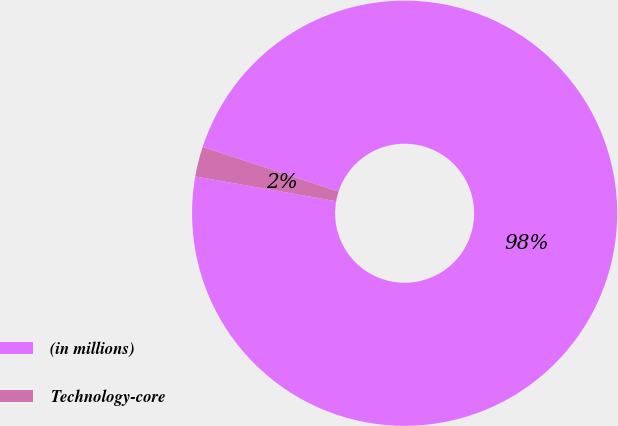Convert chart to OTSL. <chart><loc_0><loc_0><loc_500><loc_500><pie_chart><fcel>(in millions)<fcel>Technology-core<nl><fcel>97.72%<fcel>2.28%<nl></chart> 